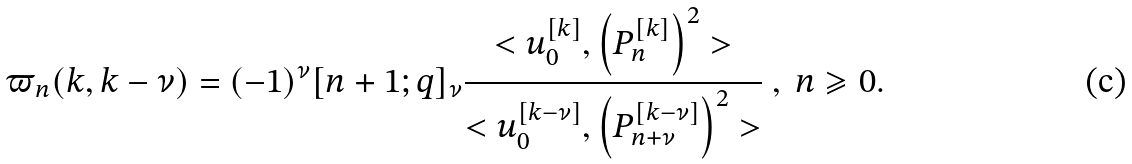<formula> <loc_0><loc_0><loc_500><loc_500>\varpi _ { n } ( k , k - \nu ) = ( - 1 ) ^ { \nu } [ n + 1 ; q ] _ { \nu } \frac { < u _ { 0 } ^ { [ k ] } , \left ( P _ { n } ^ { [ k ] } \right ) ^ { 2 } > } { < u _ { 0 } ^ { [ k - \nu ] } , \left ( P _ { n + \nu } ^ { [ k - \nu ] } \right ) ^ { 2 } > } \ , \ n \geqslant 0 .</formula> 